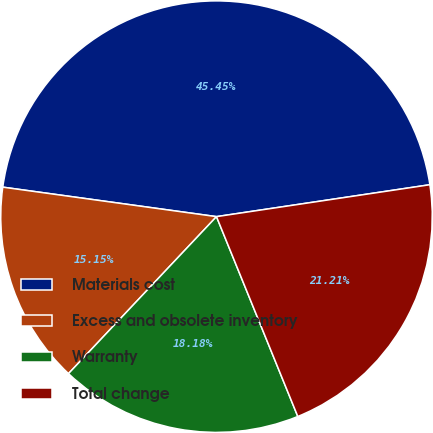Convert chart. <chart><loc_0><loc_0><loc_500><loc_500><pie_chart><fcel>Materials cost<fcel>Excess and obsolete inventory<fcel>Warranty<fcel>Total change<nl><fcel>45.45%<fcel>15.15%<fcel>18.18%<fcel>21.21%<nl></chart> 